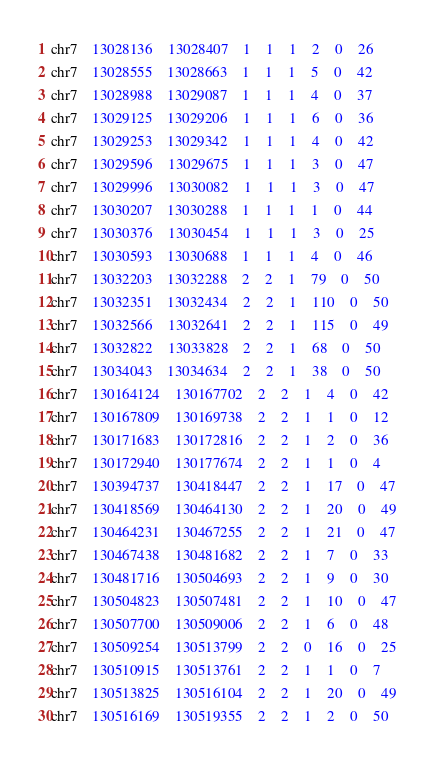<code> <loc_0><loc_0><loc_500><loc_500><_SQL_>chr7	13028136	13028407	1	1	1	2	0	26
chr7	13028555	13028663	1	1	1	5	0	42
chr7	13028988	13029087	1	1	1	4	0	37
chr7	13029125	13029206	1	1	1	6	0	36
chr7	13029253	13029342	1	1	1	4	0	42
chr7	13029596	13029675	1	1	1	3	0	47
chr7	13029996	13030082	1	1	1	3	0	47
chr7	13030207	13030288	1	1	1	1	0	44
chr7	13030376	13030454	1	1	1	3	0	25
chr7	13030593	13030688	1	1	1	4	0	46
chr7	13032203	13032288	2	2	1	79	0	50
chr7	13032351	13032434	2	2	1	110	0	50
chr7	13032566	13032641	2	2	1	115	0	49
chr7	13032822	13033828	2	2	1	68	0	50
chr7	13034043	13034634	2	2	1	38	0	50
chr7	130164124	130167702	2	2	1	4	0	42
chr7	130167809	130169738	2	2	1	1	0	12
chr7	130171683	130172816	2	2	1	2	0	36
chr7	130172940	130177674	2	2	1	1	0	4
chr7	130394737	130418447	2	2	1	17	0	47
chr7	130418569	130464130	2	2	1	20	0	49
chr7	130464231	130467255	2	2	1	21	0	47
chr7	130467438	130481682	2	2	1	7	0	33
chr7	130481716	130504693	2	2	1	9	0	30
chr7	130504823	130507481	2	2	1	10	0	47
chr7	130507700	130509006	2	2	1	6	0	48
chr7	130509254	130513799	2	2	0	16	0	25
chr7	130510915	130513761	2	2	1	1	0	7
chr7	130513825	130516104	2	2	1	20	0	49
chr7	130516169	130519355	2	2	1	2	0	50</code> 